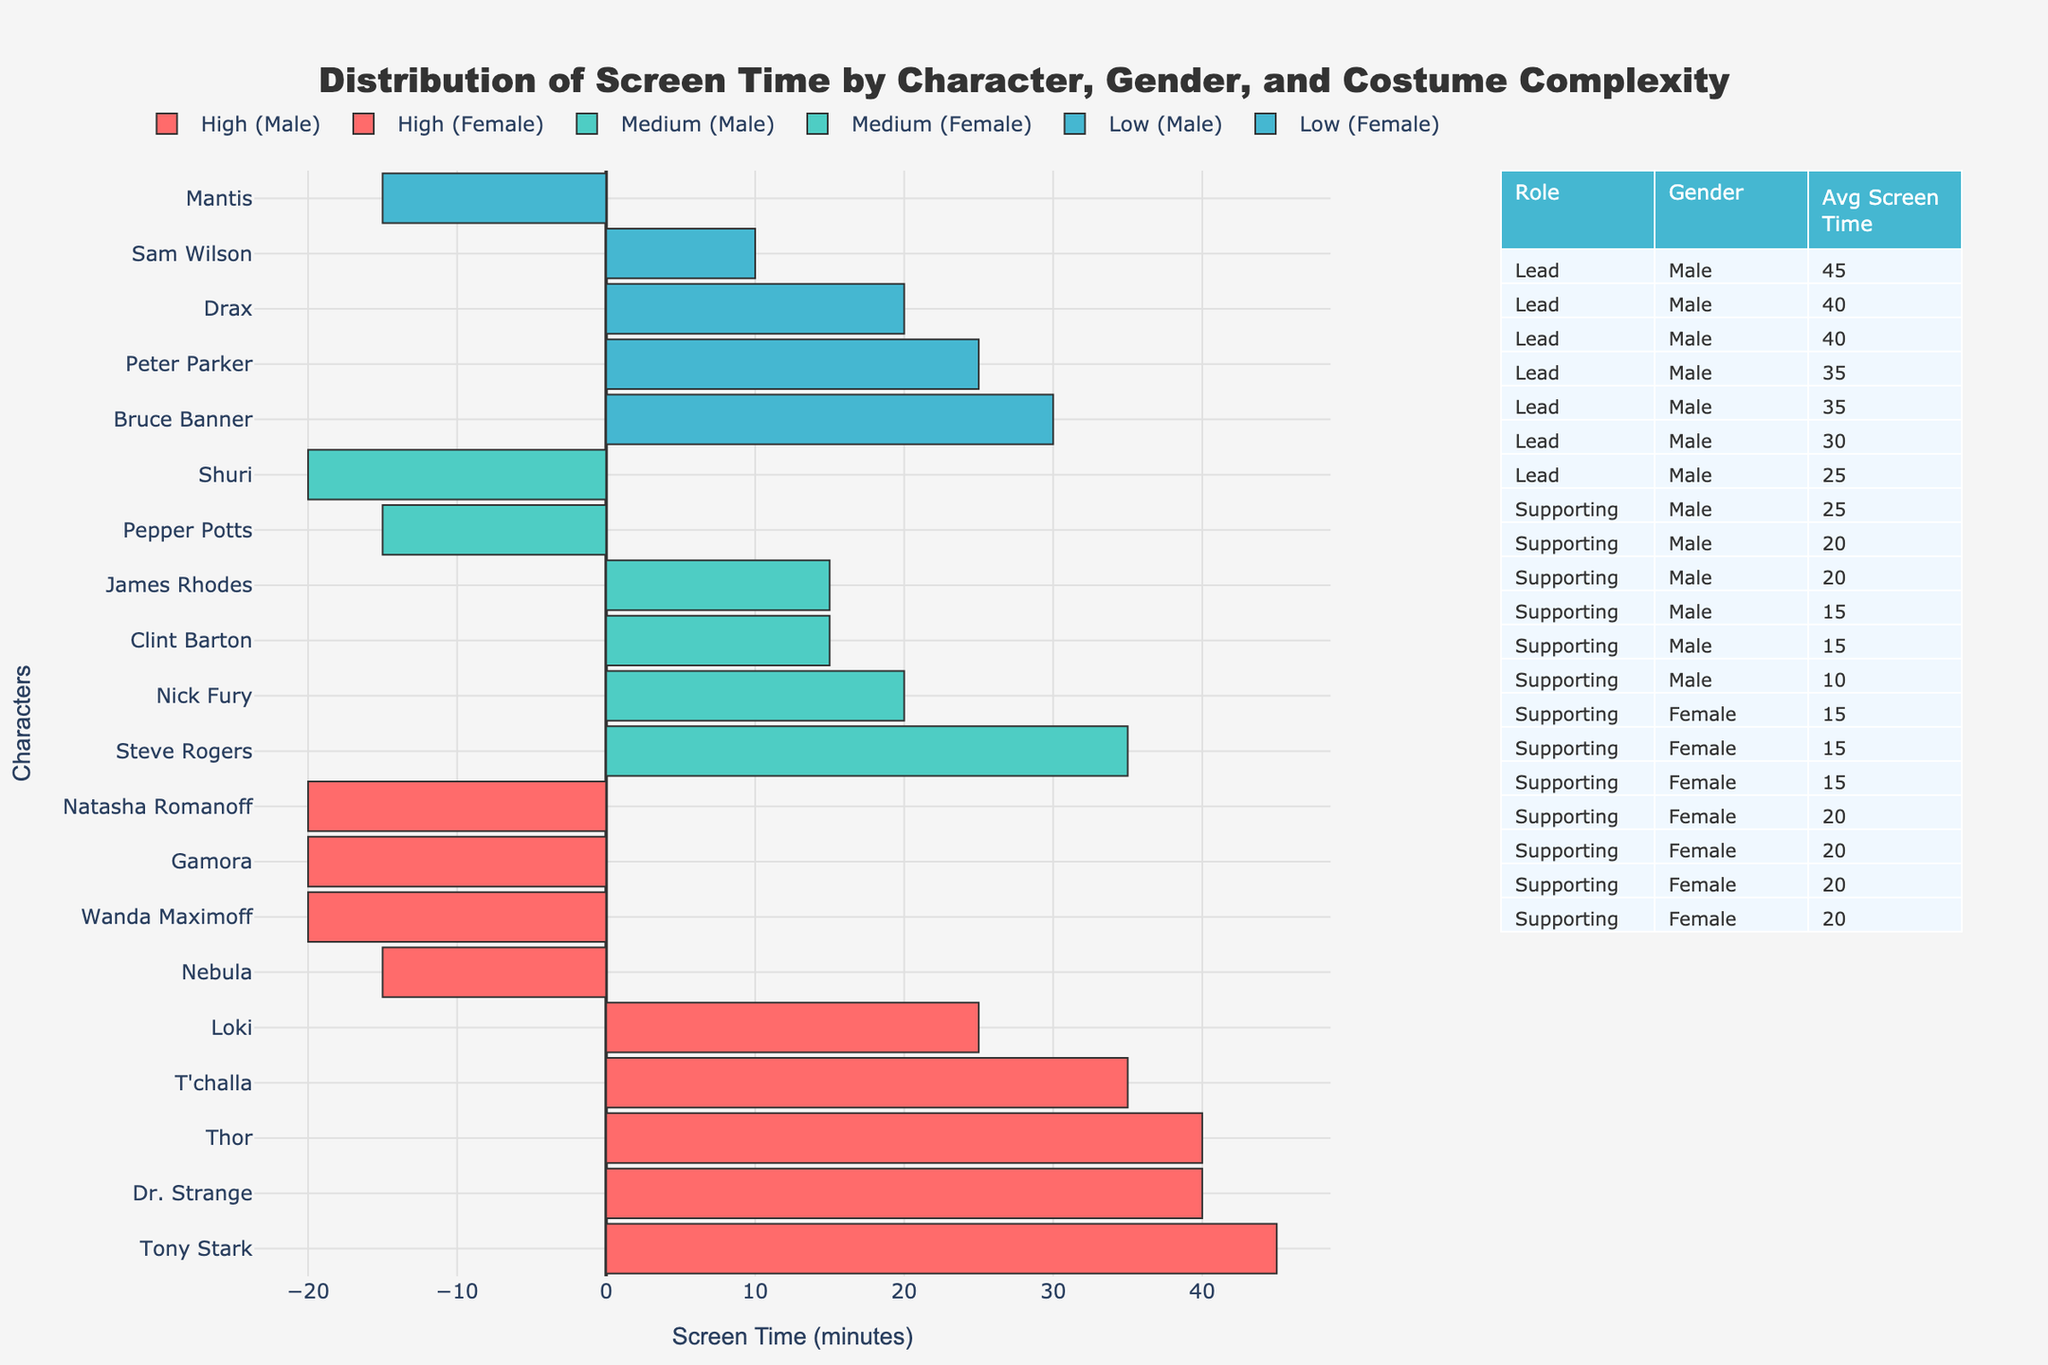What is the total screen time for all male characters? To find the total screen time for male characters, sum the values in the bar chart that represent male characters. These values are: 45, 35, 25, 40, 30, 35, 25, 15, 10, 15, 15, and 20. Adding these together: 45 + 35 + 25 + 40 + 30 + 35 + 25 + 15 + 10 + 15 + 15 + 20 = 310 minutes.
Answer: 310 How much more screen time does Tony Stark have compared to Steve Rogers? Note Tony Stark's screen time (45 minutes) and Steve Rogers' screen time (35 minutes). Subtract Steve Rogers' time from Tony Stark's: 45 - 35 = 10.
Answer: 10 minutes Which character has the highest screen time with high costume complexity? In the high complexity category, identify the bar with the greatest value. Tony Stark (45 minutes) has the highest screen time among characters with high costume complexity.
Answer: Tony Stark Among supporting female characters, who has the highest screen time? Filter the supporting female characters and compare their screen times. Natasha Romanoff and Wanda Maximoff both have the highest screen time with 20 minutes each.
Answer: Natasha Romanoff and Wanda Maximoff Are there more supporting male characters or lead female characters? Count the number of entries for supporting male characters and lead female characters. There are 7 supporting male characters and 0 lead female characters. Since 7 is greater than 0, there are more supporting male characters.
Answer: Supporting male characters What's the average screen time for all supporting characters? Sum the screen times for supporting characters: 15 (Pepper) + 20 (Natasha) + 20 (Wanda) + 25 (Loki) + 15 (Clint) + 10 (Sam) + 20 (Nick) + 15 (Nebula) + 15 (Mantis) + 20 (Drax) + 20 (Shuri) + 15 (James) = 200. There are 12 supporting characters, so the average screen time = 200 / 12 = ~16.67 minutes.
Answer: ~16.67 Which character has the lowest screen time, and what is their costume complexity? Identify the character with the smallest bar length. Sam Wilson has the lowest screen time with 10 minutes and has low costume complexity.
Answer: Sam Wilson (Low) 